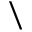Convert formula to latex. <formula><loc_0><loc_0><loc_500><loc_500>\</formula> 